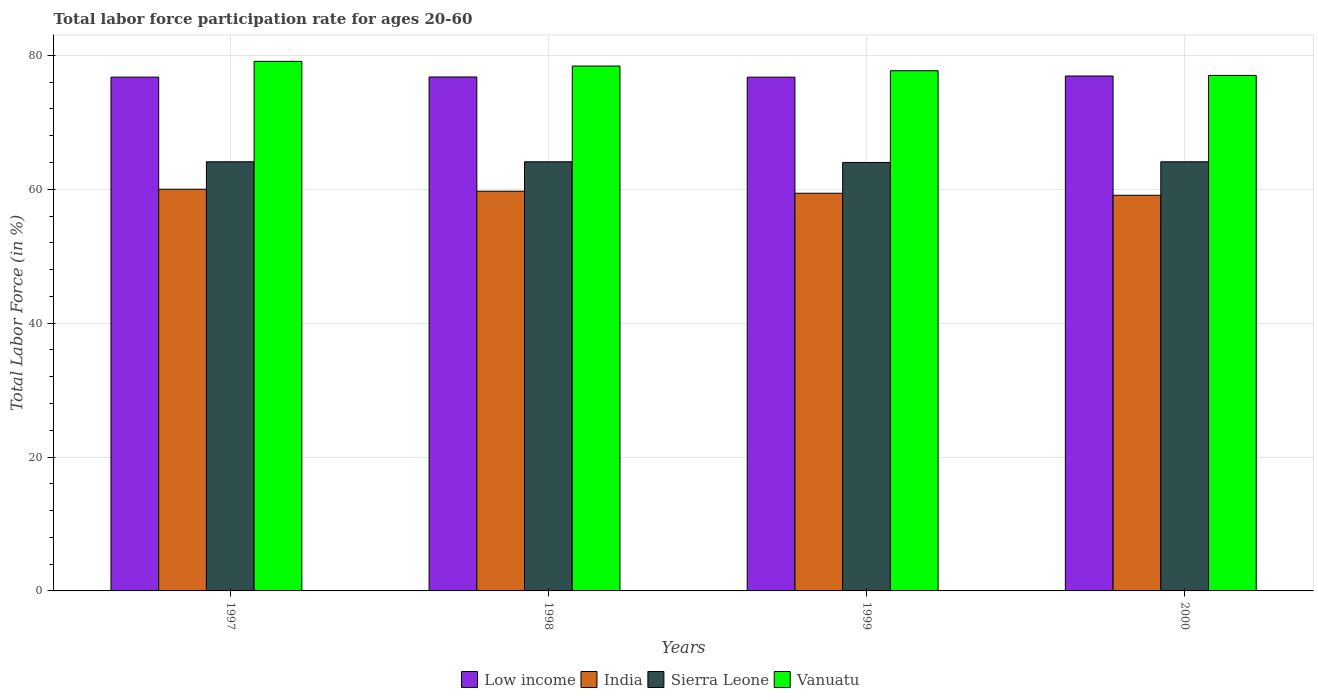How many different coloured bars are there?
Make the answer very short. 4. Are the number of bars per tick equal to the number of legend labels?
Your answer should be very brief. Yes. Are the number of bars on each tick of the X-axis equal?
Ensure brevity in your answer.  Yes. How many bars are there on the 3rd tick from the right?
Provide a short and direct response. 4. What is the label of the 1st group of bars from the left?
Your response must be concise. 1997. What is the labor force participation rate in India in 1999?
Your answer should be compact. 59.4. Across all years, what is the maximum labor force participation rate in India?
Your response must be concise. 60. In which year was the labor force participation rate in India maximum?
Make the answer very short. 1997. In which year was the labor force participation rate in India minimum?
Your answer should be compact. 2000. What is the total labor force participation rate in Low income in the graph?
Your response must be concise. 307.16. What is the difference between the labor force participation rate in Low income in 1998 and that in 2000?
Your answer should be very brief. -0.14. What is the difference between the labor force participation rate in Vanuatu in 2000 and the labor force participation rate in India in 1997?
Make the answer very short. 17. What is the average labor force participation rate in Low income per year?
Keep it short and to the point. 76.79. In the year 1999, what is the difference between the labor force participation rate in India and labor force participation rate in Low income?
Give a very brief answer. -17.34. In how many years, is the labor force participation rate in India greater than 72 %?
Your response must be concise. 0. What is the ratio of the labor force participation rate in India in 1997 to that in 1999?
Your answer should be compact. 1.01. Is the labor force participation rate in Vanuatu in 1999 less than that in 2000?
Offer a very short reply. No. What is the difference between the highest and the second highest labor force participation rate in Low income?
Your answer should be compact. 0.14. What is the difference between the highest and the lowest labor force participation rate in Low income?
Ensure brevity in your answer.  0.17. In how many years, is the labor force participation rate in Vanuatu greater than the average labor force participation rate in Vanuatu taken over all years?
Make the answer very short. 2. Is the sum of the labor force participation rate in Vanuatu in 1997 and 1998 greater than the maximum labor force participation rate in Sierra Leone across all years?
Offer a very short reply. Yes. What does the 3rd bar from the left in 1997 represents?
Your answer should be very brief. Sierra Leone. What does the 1st bar from the right in 2000 represents?
Make the answer very short. Vanuatu. Are all the bars in the graph horizontal?
Offer a very short reply. No. What is the difference between two consecutive major ticks on the Y-axis?
Your answer should be very brief. 20. Does the graph contain any zero values?
Your response must be concise. No. How many legend labels are there?
Give a very brief answer. 4. What is the title of the graph?
Offer a very short reply. Total labor force participation rate for ages 20-60. What is the label or title of the Y-axis?
Ensure brevity in your answer.  Total Labor Force (in %). What is the Total Labor Force (in %) in Low income in 1997?
Your answer should be very brief. 76.74. What is the Total Labor Force (in %) of India in 1997?
Keep it short and to the point. 60. What is the Total Labor Force (in %) in Sierra Leone in 1997?
Your answer should be compact. 64.1. What is the Total Labor Force (in %) of Vanuatu in 1997?
Offer a terse response. 79.1. What is the Total Labor Force (in %) of Low income in 1998?
Provide a short and direct response. 76.77. What is the Total Labor Force (in %) of India in 1998?
Provide a succinct answer. 59.7. What is the Total Labor Force (in %) of Sierra Leone in 1998?
Ensure brevity in your answer.  64.1. What is the Total Labor Force (in %) in Vanuatu in 1998?
Give a very brief answer. 78.4. What is the Total Labor Force (in %) in Low income in 1999?
Keep it short and to the point. 76.74. What is the Total Labor Force (in %) of India in 1999?
Make the answer very short. 59.4. What is the Total Labor Force (in %) in Vanuatu in 1999?
Give a very brief answer. 77.7. What is the Total Labor Force (in %) in Low income in 2000?
Keep it short and to the point. 76.91. What is the Total Labor Force (in %) in India in 2000?
Provide a short and direct response. 59.1. What is the Total Labor Force (in %) of Sierra Leone in 2000?
Offer a terse response. 64.1. What is the Total Labor Force (in %) in Vanuatu in 2000?
Provide a succinct answer. 77. Across all years, what is the maximum Total Labor Force (in %) in Low income?
Make the answer very short. 76.91. Across all years, what is the maximum Total Labor Force (in %) of India?
Make the answer very short. 60. Across all years, what is the maximum Total Labor Force (in %) of Sierra Leone?
Ensure brevity in your answer.  64.1. Across all years, what is the maximum Total Labor Force (in %) of Vanuatu?
Your answer should be very brief. 79.1. Across all years, what is the minimum Total Labor Force (in %) in Low income?
Your response must be concise. 76.74. Across all years, what is the minimum Total Labor Force (in %) of India?
Your response must be concise. 59.1. Across all years, what is the minimum Total Labor Force (in %) in Vanuatu?
Offer a terse response. 77. What is the total Total Labor Force (in %) in Low income in the graph?
Give a very brief answer. 307.16. What is the total Total Labor Force (in %) of India in the graph?
Your answer should be very brief. 238.2. What is the total Total Labor Force (in %) in Sierra Leone in the graph?
Provide a short and direct response. 256.3. What is the total Total Labor Force (in %) in Vanuatu in the graph?
Give a very brief answer. 312.2. What is the difference between the Total Labor Force (in %) of Low income in 1997 and that in 1998?
Offer a very short reply. -0.02. What is the difference between the Total Labor Force (in %) in Sierra Leone in 1997 and that in 1998?
Provide a succinct answer. 0. What is the difference between the Total Labor Force (in %) of Vanuatu in 1997 and that in 1998?
Ensure brevity in your answer.  0.7. What is the difference between the Total Labor Force (in %) of Low income in 1997 and that in 1999?
Give a very brief answer. 0.01. What is the difference between the Total Labor Force (in %) in India in 1997 and that in 1999?
Provide a succinct answer. 0.6. What is the difference between the Total Labor Force (in %) in Sierra Leone in 1997 and that in 1999?
Provide a succinct answer. 0.1. What is the difference between the Total Labor Force (in %) in Vanuatu in 1997 and that in 1999?
Keep it short and to the point. 1.4. What is the difference between the Total Labor Force (in %) in Low income in 1997 and that in 2000?
Offer a very short reply. -0.17. What is the difference between the Total Labor Force (in %) in India in 1997 and that in 2000?
Your response must be concise. 0.9. What is the difference between the Total Labor Force (in %) in Sierra Leone in 1997 and that in 2000?
Keep it short and to the point. 0. What is the difference between the Total Labor Force (in %) in Vanuatu in 1997 and that in 2000?
Your answer should be compact. 2.1. What is the difference between the Total Labor Force (in %) in Low income in 1998 and that in 1999?
Keep it short and to the point. 0.03. What is the difference between the Total Labor Force (in %) of India in 1998 and that in 1999?
Give a very brief answer. 0.3. What is the difference between the Total Labor Force (in %) in Sierra Leone in 1998 and that in 1999?
Keep it short and to the point. 0.1. What is the difference between the Total Labor Force (in %) of Low income in 1998 and that in 2000?
Your answer should be compact. -0.14. What is the difference between the Total Labor Force (in %) in Vanuatu in 1998 and that in 2000?
Your response must be concise. 1.4. What is the difference between the Total Labor Force (in %) of Low income in 1999 and that in 2000?
Provide a short and direct response. -0.17. What is the difference between the Total Labor Force (in %) of Sierra Leone in 1999 and that in 2000?
Offer a terse response. -0.1. What is the difference between the Total Labor Force (in %) of Low income in 1997 and the Total Labor Force (in %) of India in 1998?
Ensure brevity in your answer.  17.04. What is the difference between the Total Labor Force (in %) of Low income in 1997 and the Total Labor Force (in %) of Sierra Leone in 1998?
Offer a terse response. 12.64. What is the difference between the Total Labor Force (in %) in Low income in 1997 and the Total Labor Force (in %) in Vanuatu in 1998?
Provide a short and direct response. -1.66. What is the difference between the Total Labor Force (in %) of India in 1997 and the Total Labor Force (in %) of Sierra Leone in 1998?
Offer a very short reply. -4.1. What is the difference between the Total Labor Force (in %) of India in 1997 and the Total Labor Force (in %) of Vanuatu in 1998?
Provide a short and direct response. -18.4. What is the difference between the Total Labor Force (in %) in Sierra Leone in 1997 and the Total Labor Force (in %) in Vanuatu in 1998?
Keep it short and to the point. -14.3. What is the difference between the Total Labor Force (in %) of Low income in 1997 and the Total Labor Force (in %) of India in 1999?
Ensure brevity in your answer.  17.34. What is the difference between the Total Labor Force (in %) in Low income in 1997 and the Total Labor Force (in %) in Sierra Leone in 1999?
Keep it short and to the point. 12.74. What is the difference between the Total Labor Force (in %) in Low income in 1997 and the Total Labor Force (in %) in Vanuatu in 1999?
Your answer should be compact. -0.96. What is the difference between the Total Labor Force (in %) of India in 1997 and the Total Labor Force (in %) of Vanuatu in 1999?
Give a very brief answer. -17.7. What is the difference between the Total Labor Force (in %) in Sierra Leone in 1997 and the Total Labor Force (in %) in Vanuatu in 1999?
Give a very brief answer. -13.6. What is the difference between the Total Labor Force (in %) in Low income in 1997 and the Total Labor Force (in %) in India in 2000?
Provide a short and direct response. 17.64. What is the difference between the Total Labor Force (in %) in Low income in 1997 and the Total Labor Force (in %) in Sierra Leone in 2000?
Provide a short and direct response. 12.64. What is the difference between the Total Labor Force (in %) of Low income in 1997 and the Total Labor Force (in %) of Vanuatu in 2000?
Your answer should be compact. -0.26. What is the difference between the Total Labor Force (in %) of India in 1997 and the Total Labor Force (in %) of Vanuatu in 2000?
Provide a short and direct response. -17. What is the difference between the Total Labor Force (in %) in Sierra Leone in 1997 and the Total Labor Force (in %) in Vanuatu in 2000?
Your response must be concise. -12.9. What is the difference between the Total Labor Force (in %) of Low income in 1998 and the Total Labor Force (in %) of India in 1999?
Ensure brevity in your answer.  17.37. What is the difference between the Total Labor Force (in %) in Low income in 1998 and the Total Labor Force (in %) in Sierra Leone in 1999?
Keep it short and to the point. 12.77. What is the difference between the Total Labor Force (in %) of Low income in 1998 and the Total Labor Force (in %) of Vanuatu in 1999?
Your answer should be very brief. -0.93. What is the difference between the Total Labor Force (in %) of India in 1998 and the Total Labor Force (in %) of Sierra Leone in 1999?
Provide a short and direct response. -4.3. What is the difference between the Total Labor Force (in %) of Low income in 1998 and the Total Labor Force (in %) of India in 2000?
Ensure brevity in your answer.  17.67. What is the difference between the Total Labor Force (in %) of Low income in 1998 and the Total Labor Force (in %) of Sierra Leone in 2000?
Your answer should be very brief. 12.67. What is the difference between the Total Labor Force (in %) in Low income in 1998 and the Total Labor Force (in %) in Vanuatu in 2000?
Provide a short and direct response. -0.23. What is the difference between the Total Labor Force (in %) in India in 1998 and the Total Labor Force (in %) in Sierra Leone in 2000?
Offer a terse response. -4.4. What is the difference between the Total Labor Force (in %) of India in 1998 and the Total Labor Force (in %) of Vanuatu in 2000?
Offer a very short reply. -17.3. What is the difference between the Total Labor Force (in %) in Sierra Leone in 1998 and the Total Labor Force (in %) in Vanuatu in 2000?
Ensure brevity in your answer.  -12.9. What is the difference between the Total Labor Force (in %) in Low income in 1999 and the Total Labor Force (in %) in India in 2000?
Your answer should be compact. 17.64. What is the difference between the Total Labor Force (in %) of Low income in 1999 and the Total Labor Force (in %) of Sierra Leone in 2000?
Provide a succinct answer. 12.64. What is the difference between the Total Labor Force (in %) in Low income in 1999 and the Total Labor Force (in %) in Vanuatu in 2000?
Your answer should be compact. -0.26. What is the difference between the Total Labor Force (in %) in India in 1999 and the Total Labor Force (in %) in Sierra Leone in 2000?
Give a very brief answer. -4.7. What is the difference between the Total Labor Force (in %) of India in 1999 and the Total Labor Force (in %) of Vanuatu in 2000?
Keep it short and to the point. -17.6. What is the difference between the Total Labor Force (in %) of Sierra Leone in 1999 and the Total Labor Force (in %) of Vanuatu in 2000?
Provide a succinct answer. -13. What is the average Total Labor Force (in %) in Low income per year?
Your answer should be compact. 76.79. What is the average Total Labor Force (in %) in India per year?
Make the answer very short. 59.55. What is the average Total Labor Force (in %) in Sierra Leone per year?
Your answer should be compact. 64.08. What is the average Total Labor Force (in %) of Vanuatu per year?
Give a very brief answer. 78.05. In the year 1997, what is the difference between the Total Labor Force (in %) in Low income and Total Labor Force (in %) in India?
Make the answer very short. 16.74. In the year 1997, what is the difference between the Total Labor Force (in %) in Low income and Total Labor Force (in %) in Sierra Leone?
Offer a terse response. 12.64. In the year 1997, what is the difference between the Total Labor Force (in %) in Low income and Total Labor Force (in %) in Vanuatu?
Your answer should be very brief. -2.36. In the year 1997, what is the difference between the Total Labor Force (in %) in India and Total Labor Force (in %) in Vanuatu?
Give a very brief answer. -19.1. In the year 1997, what is the difference between the Total Labor Force (in %) of Sierra Leone and Total Labor Force (in %) of Vanuatu?
Keep it short and to the point. -15. In the year 1998, what is the difference between the Total Labor Force (in %) of Low income and Total Labor Force (in %) of India?
Offer a terse response. 17.07. In the year 1998, what is the difference between the Total Labor Force (in %) in Low income and Total Labor Force (in %) in Sierra Leone?
Your answer should be very brief. 12.67. In the year 1998, what is the difference between the Total Labor Force (in %) in Low income and Total Labor Force (in %) in Vanuatu?
Give a very brief answer. -1.63. In the year 1998, what is the difference between the Total Labor Force (in %) in India and Total Labor Force (in %) in Vanuatu?
Your answer should be compact. -18.7. In the year 1998, what is the difference between the Total Labor Force (in %) of Sierra Leone and Total Labor Force (in %) of Vanuatu?
Your answer should be compact. -14.3. In the year 1999, what is the difference between the Total Labor Force (in %) in Low income and Total Labor Force (in %) in India?
Your answer should be very brief. 17.34. In the year 1999, what is the difference between the Total Labor Force (in %) of Low income and Total Labor Force (in %) of Sierra Leone?
Your answer should be compact. 12.74. In the year 1999, what is the difference between the Total Labor Force (in %) of Low income and Total Labor Force (in %) of Vanuatu?
Keep it short and to the point. -0.96. In the year 1999, what is the difference between the Total Labor Force (in %) in India and Total Labor Force (in %) in Sierra Leone?
Offer a terse response. -4.6. In the year 1999, what is the difference between the Total Labor Force (in %) of India and Total Labor Force (in %) of Vanuatu?
Make the answer very short. -18.3. In the year 1999, what is the difference between the Total Labor Force (in %) in Sierra Leone and Total Labor Force (in %) in Vanuatu?
Your answer should be compact. -13.7. In the year 2000, what is the difference between the Total Labor Force (in %) in Low income and Total Labor Force (in %) in India?
Your response must be concise. 17.81. In the year 2000, what is the difference between the Total Labor Force (in %) of Low income and Total Labor Force (in %) of Sierra Leone?
Your answer should be very brief. 12.81. In the year 2000, what is the difference between the Total Labor Force (in %) of Low income and Total Labor Force (in %) of Vanuatu?
Make the answer very short. -0.09. In the year 2000, what is the difference between the Total Labor Force (in %) in India and Total Labor Force (in %) in Vanuatu?
Keep it short and to the point. -17.9. In the year 2000, what is the difference between the Total Labor Force (in %) of Sierra Leone and Total Labor Force (in %) of Vanuatu?
Provide a short and direct response. -12.9. What is the ratio of the Total Labor Force (in %) in India in 1997 to that in 1998?
Provide a succinct answer. 1. What is the ratio of the Total Labor Force (in %) of Sierra Leone in 1997 to that in 1998?
Give a very brief answer. 1. What is the ratio of the Total Labor Force (in %) of Vanuatu in 1997 to that in 1998?
Give a very brief answer. 1.01. What is the ratio of the Total Labor Force (in %) in Low income in 1997 to that in 2000?
Give a very brief answer. 1. What is the ratio of the Total Labor Force (in %) of India in 1997 to that in 2000?
Make the answer very short. 1.02. What is the ratio of the Total Labor Force (in %) of Vanuatu in 1997 to that in 2000?
Your response must be concise. 1.03. What is the ratio of the Total Labor Force (in %) in Low income in 1998 to that in 1999?
Ensure brevity in your answer.  1. What is the ratio of the Total Labor Force (in %) in Sierra Leone in 1998 to that in 1999?
Your response must be concise. 1. What is the ratio of the Total Labor Force (in %) of India in 1998 to that in 2000?
Keep it short and to the point. 1.01. What is the ratio of the Total Labor Force (in %) of Vanuatu in 1998 to that in 2000?
Offer a terse response. 1.02. What is the ratio of the Total Labor Force (in %) in Sierra Leone in 1999 to that in 2000?
Your answer should be very brief. 1. What is the ratio of the Total Labor Force (in %) in Vanuatu in 1999 to that in 2000?
Provide a succinct answer. 1.01. What is the difference between the highest and the second highest Total Labor Force (in %) of Low income?
Keep it short and to the point. 0.14. What is the difference between the highest and the second highest Total Labor Force (in %) in India?
Keep it short and to the point. 0.3. What is the difference between the highest and the second highest Total Labor Force (in %) of Sierra Leone?
Keep it short and to the point. 0. What is the difference between the highest and the lowest Total Labor Force (in %) of Low income?
Provide a short and direct response. 0.17. What is the difference between the highest and the lowest Total Labor Force (in %) in Vanuatu?
Your response must be concise. 2.1. 